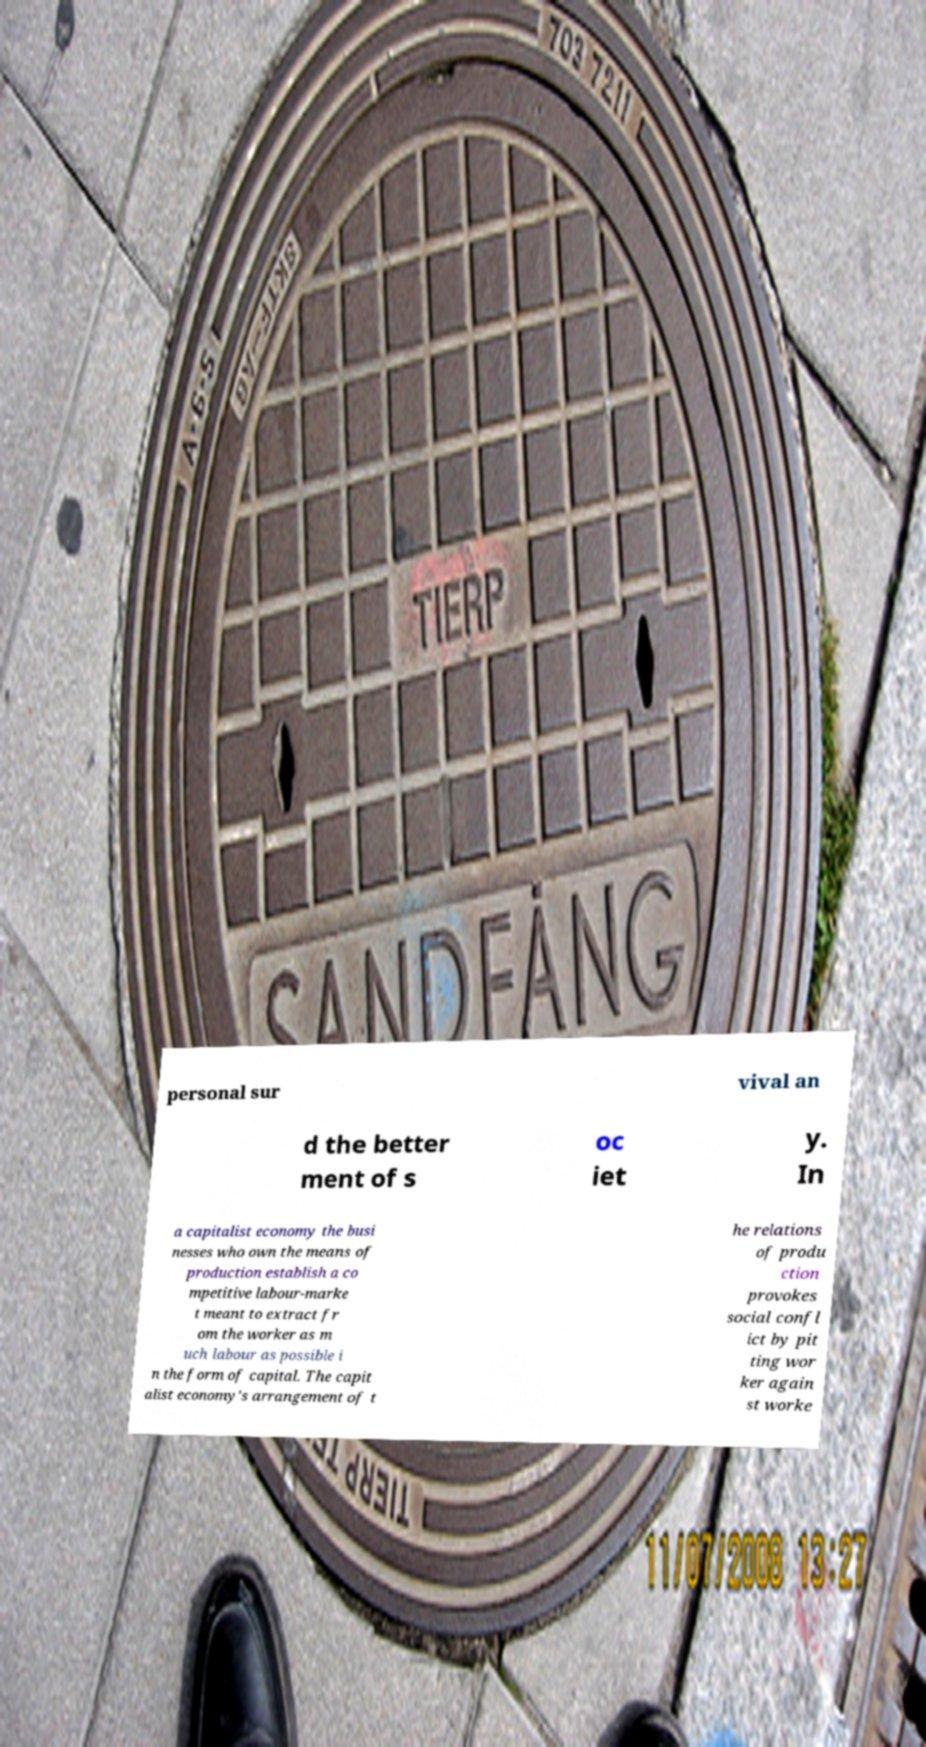Could you assist in decoding the text presented in this image and type it out clearly? personal sur vival an d the better ment of s oc iet y. In a capitalist economy the busi nesses who own the means of production establish a co mpetitive labour-marke t meant to extract fr om the worker as m uch labour as possible i n the form of capital. The capit alist economy's arrangement of t he relations of produ ction provokes social confl ict by pit ting wor ker again st worke 